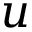<formula> <loc_0><loc_0><loc_500><loc_500>u</formula> 